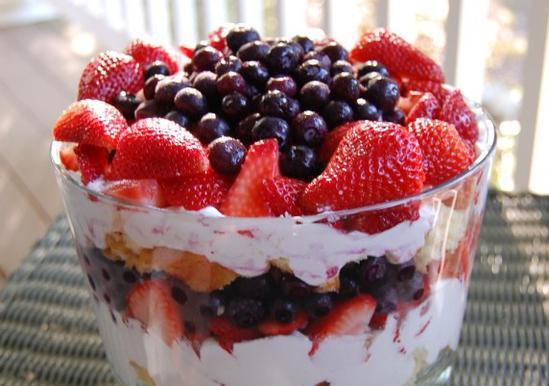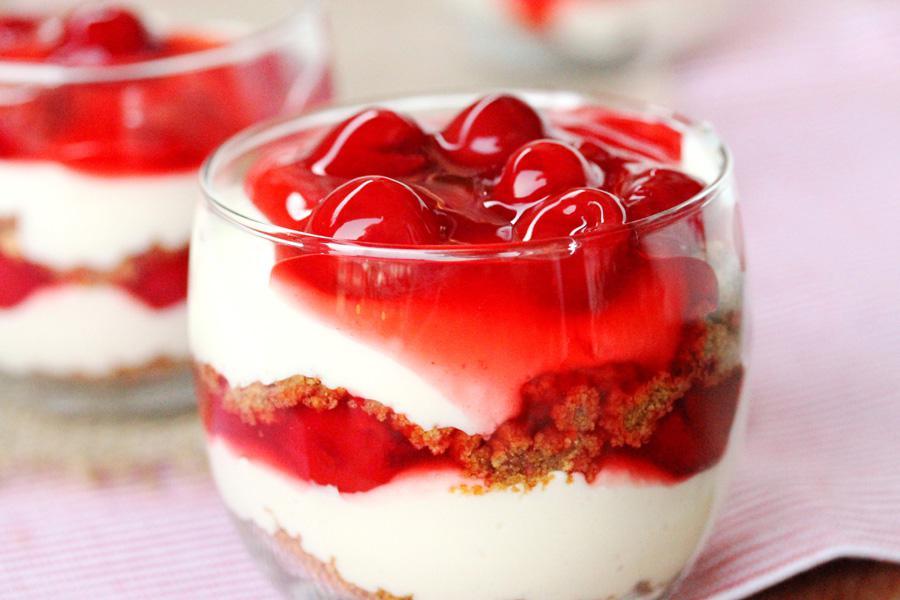The first image is the image on the left, the second image is the image on the right. Analyze the images presented: Is the assertion "There are two dessert cups sitting in a diagonal line in the image on the right." valid? Answer yes or no. Yes. The first image is the image on the left, the second image is the image on the right. Assess this claim about the two images: "There is one large trifle bowl that has fresh strawberries and blueberries on top.". Correct or not? Answer yes or no. Yes. 